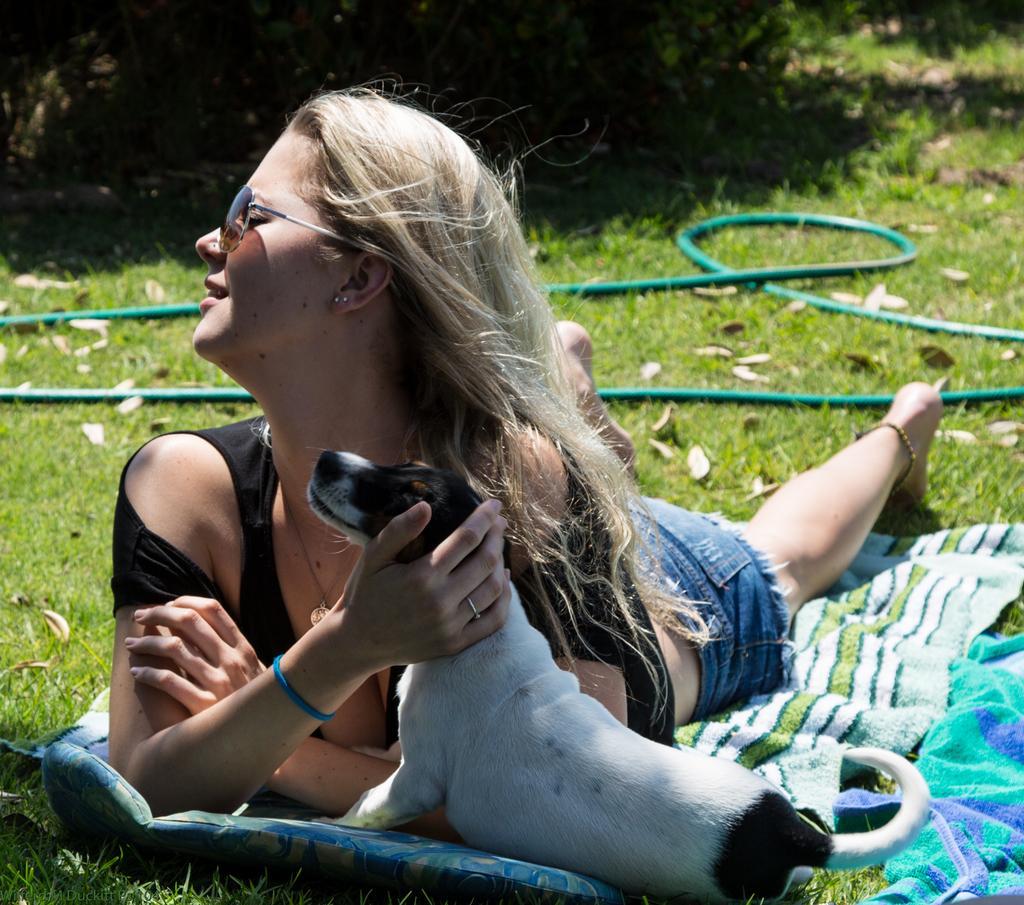Please provide a concise description of this image. In this image I can see a person laying and holding the dog. 